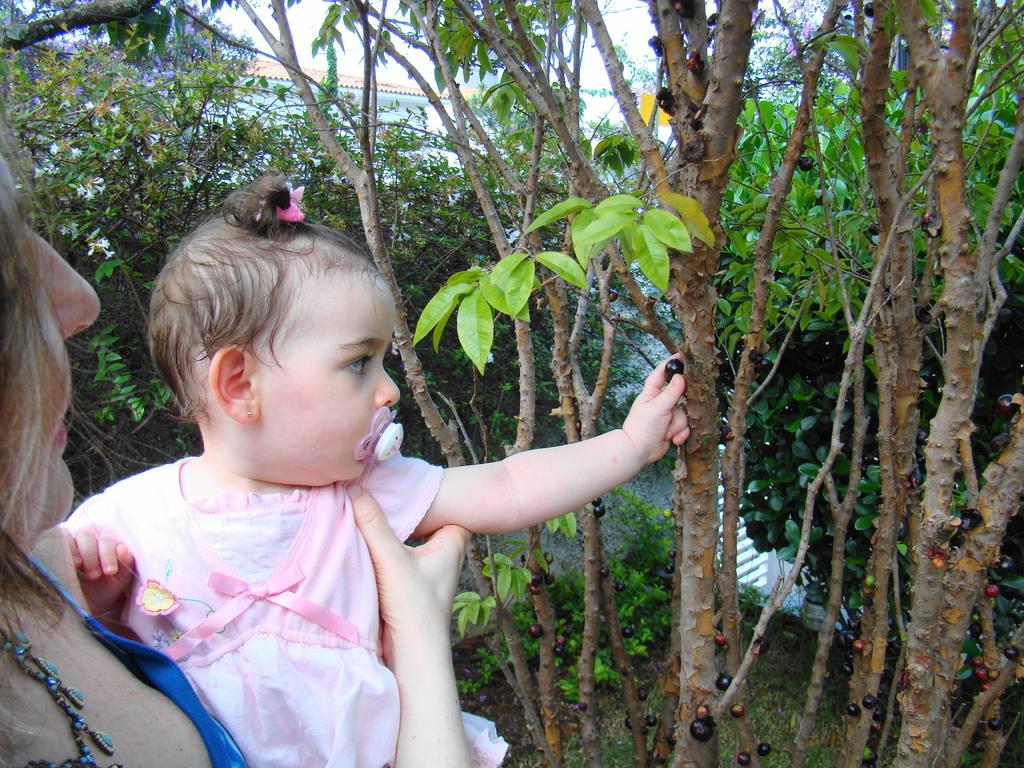Who is the main subject in the picture? There is a woman in the picture. What is the woman doing in the image? The woman is carrying a baby. What is the baby holding in the image? The baby is holding a berry. What can be seen in the background of the picture? There are trees in the background of the picture. What time of day is it in the picture, and how does the baby look in the morning? The time of day is not mentioned in the image, and there is no indication of how the baby looks in the morning. 